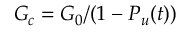<formula> <loc_0><loc_0><loc_500><loc_500>G _ { c } = G _ { 0 } / ( 1 - P _ { u } ( t ) )</formula> 